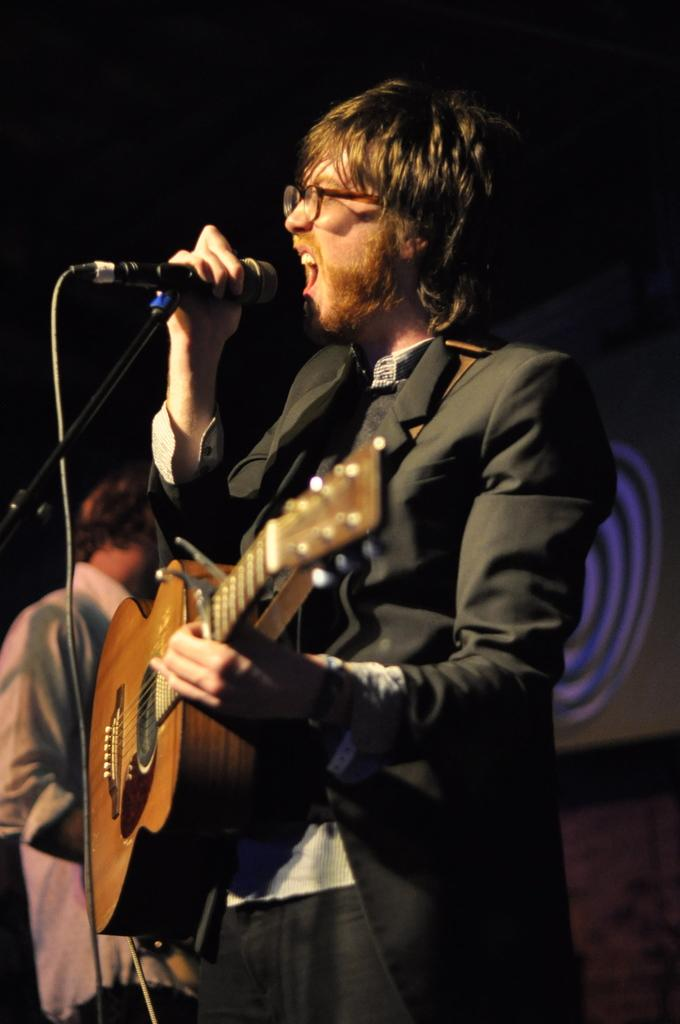Who is the main subject in the image? There is a man in the image. What is the man doing in the image? The man is singing and playing a guitar. What object is in front of the man? There is a microphone in front of the man. What type of branch is the man using to polish the guitar in the image? There is no branch or polishing activity present in the image. 